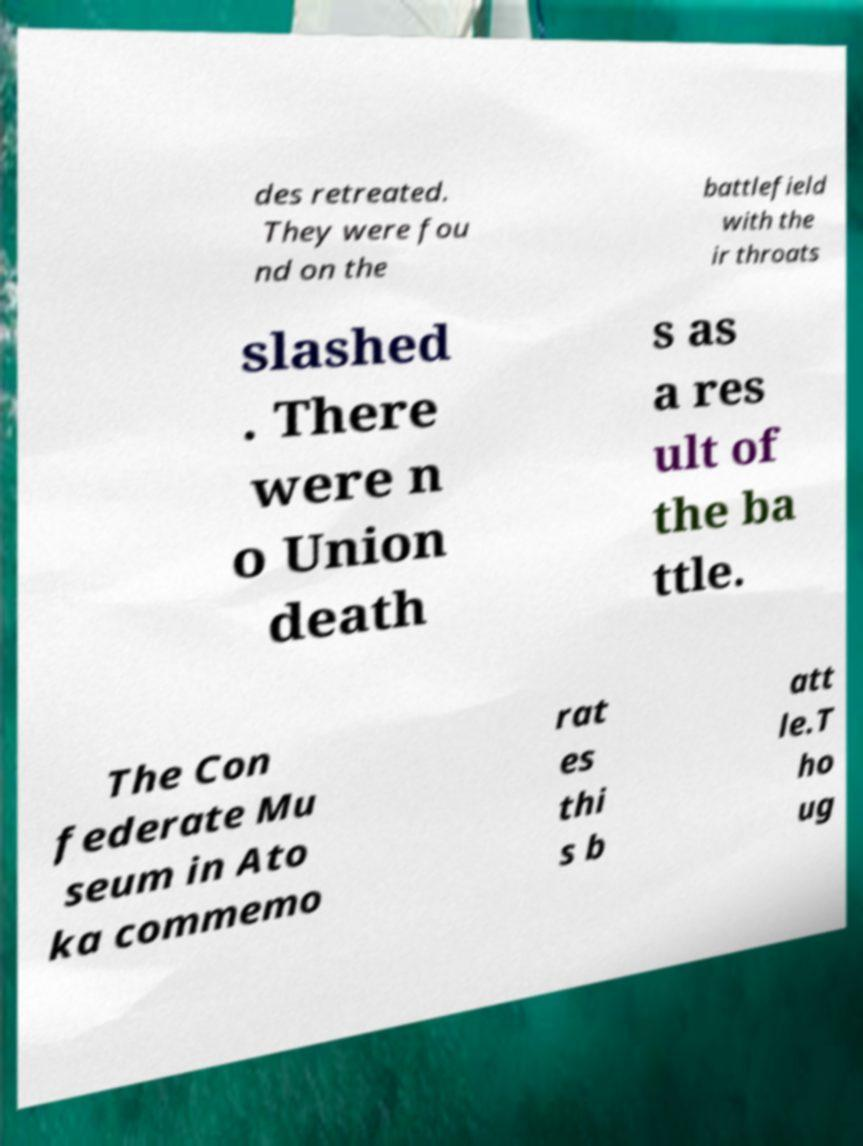What messages or text are displayed in this image? I need them in a readable, typed format. des retreated. They were fou nd on the battlefield with the ir throats slashed . There were n o Union death s as a res ult of the ba ttle. The Con federate Mu seum in Ato ka commemo rat es thi s b att le.T ho ug 